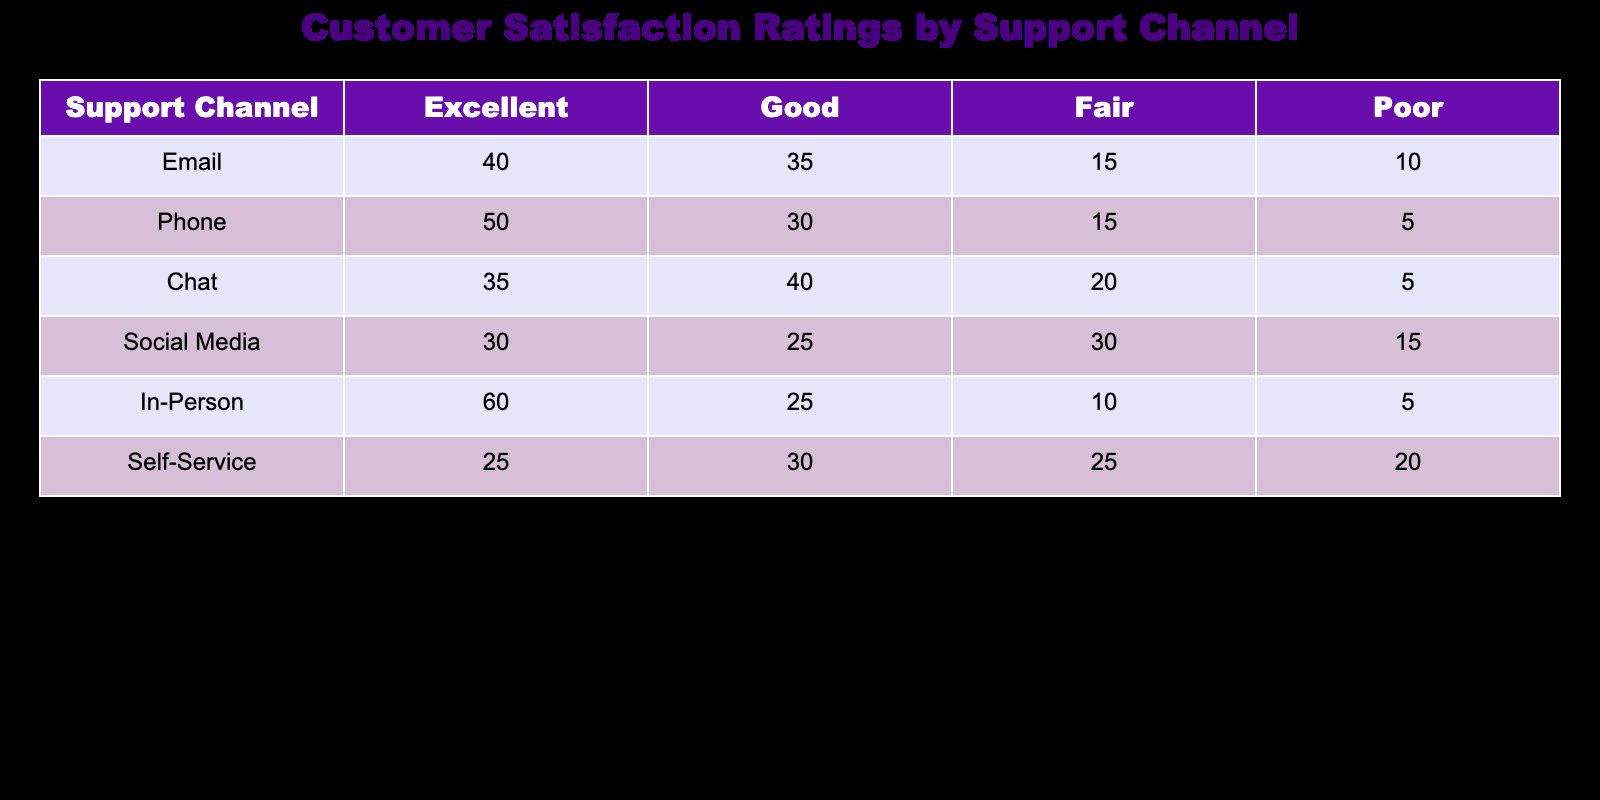What is the highest number of "Excellent" ratings for a support channel? The "Excellent" ratings for each support channel are as follows: Email: 40, Phone: 50, Chat: 35, Social Media: 30, In-Person: 60, Self-Service: 25. Among these, In-Person has the highest with 60 ratings.
Answer: 60 Which support channel has the lowest number of "Poor" ratings? The "Poor" ratings for each support channel are as follows: Email: 10, Phone: 5, Chat: 5, Social Media: 15, In-Person: 5, Self-Service: 20. The channels with the lowest number of "Poor" ratings are Phone, Chat, and In-Person, each with 5 ratings.
Answer: 5 What is the total number of "Good" ratings across all support channels? The "Good" ratings are: Email: 35, Phone: 30, Chat: 40, Social Media: 25, In-Person: 25, Self-Service: 30. Summing these gives 35 + 30 + 40 + 25 + 25 + 30 = 215.
Answer: 215 Is the number of "Fair" ratings for the Chat channel higher than that of the Social Media channel? The "Fair" ratings are as follows: Chat: 20 and Social Media: 30. Since 20 is less than 30, the statement is false.
Answer: No What percentage of In-Person ratings are "Excellent"? The total ratings for In-Person are (60 + 25 + 10 + 5) = 100. The number of "Excellent" ratings is 60. To find the percentage, (60/100) * 100 = 60%.
Answer: 60% Which support channel has the second highest number of total ratings? First, we find the total ratings for each channel: Email (40+35+15+10=100), Phone (50+30+15+5=100), Chat (35+40+20+5=100), Social Media (30+25+30+15=100), In-Person (60+25+10+5=100), Self-Service (25+30+25+20=100). Since all channels have 100 ratings, none can be said to have the second highest as they all tie.
Answer: No channel has a second highest What is the difference between the number of "Excellent" ratings for Email and Self-Service? Email has 40 "Excellent" ratings and Self-Service has 25. The difference is 40 - 25 = 15.
Answer: 15 How many support channels have an equal number of "Fair" ratings? The “Fair” ratings are: Email: 15, Phone: 15, Chat: 20, Social Media: 30, In-Person: 10, Self-Service: 25. The channels with equal "Fair" ratings are Email and Phone, both with 15. Thus, there are 2 channels with equal ratings.
Answer: 2 